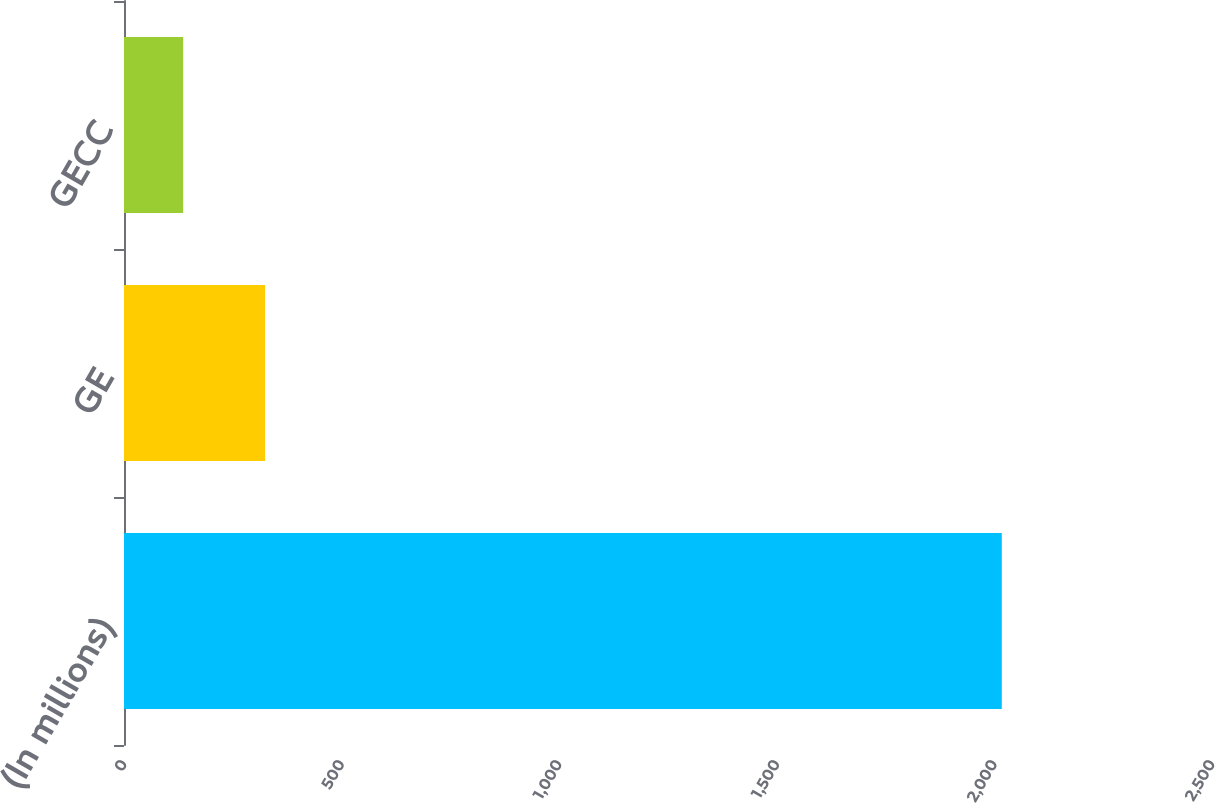<chart> <loc_0><loc_0><loc_500><loc_500><bar_chart><fcel>(In millions)<fcel>GE<fcel>GECC<nl><fcel>2017<fcel>324.1<fcel>136<nl></chart> 